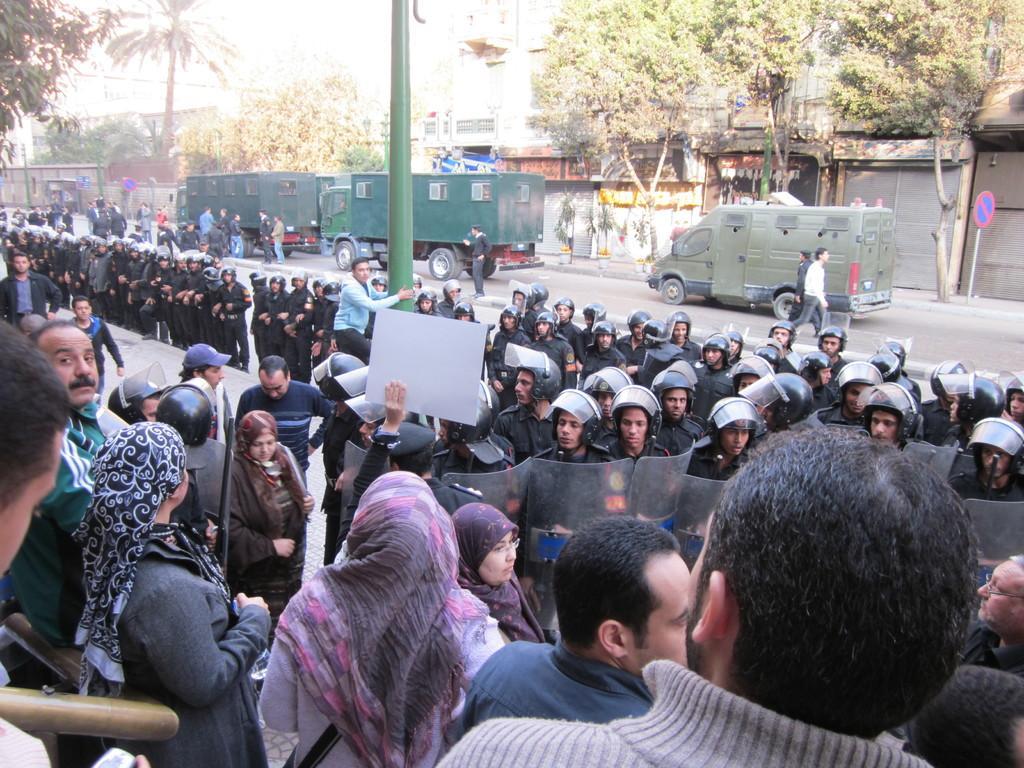Can you describe this image briefly? In this image there are a group of people some of them are holding some placards, and some of them are wearing helmets and holding some boards. And in the background there are some vehicles, and some people are walking. And there is a pavement and there are some buildings, trees, poles, boards, plants and some objects. 